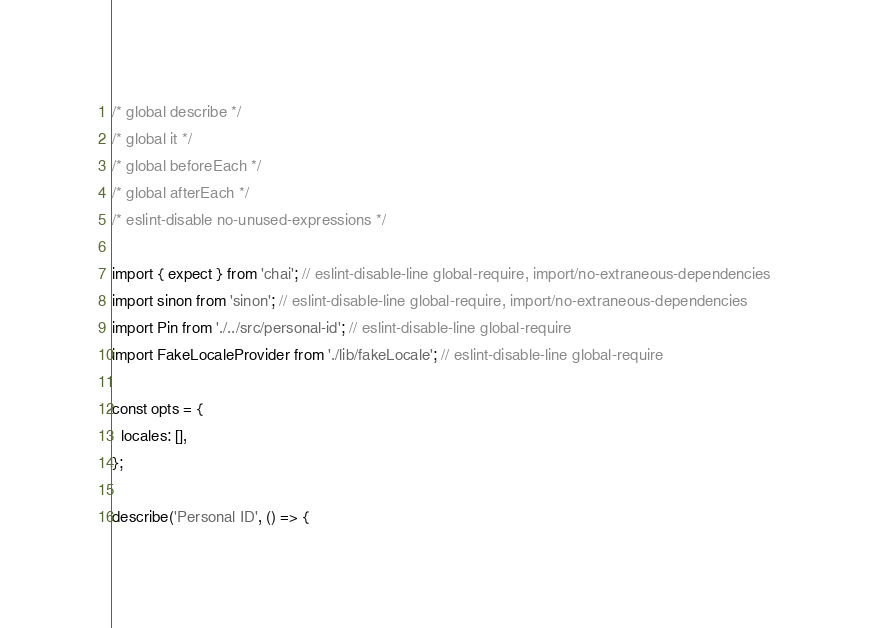<code> <loc_0><loc_0><loc_500><loc_500><_JavaScript_>/* global describe */
/* global it */
/* global beforeEach */
/* global afterEach */
/* eslint-disable no-unused-expressions */

import { expect } from 'chai'; // eslint-disable-line global-require, import/no-extraneous-dependencies
import sinon from 'sinon'; // eslint-disable-line global-require, import/no-extraneous-dependencies
import Pin from './../src/personal-id'; // eslint-disable-line global-require
import FakeLocaleProvider from './lib/fakeLocale'; // eslint-disable-line global-require

const opts = {
  locales: [],
};

describe('Personal ID', () => {</code> 